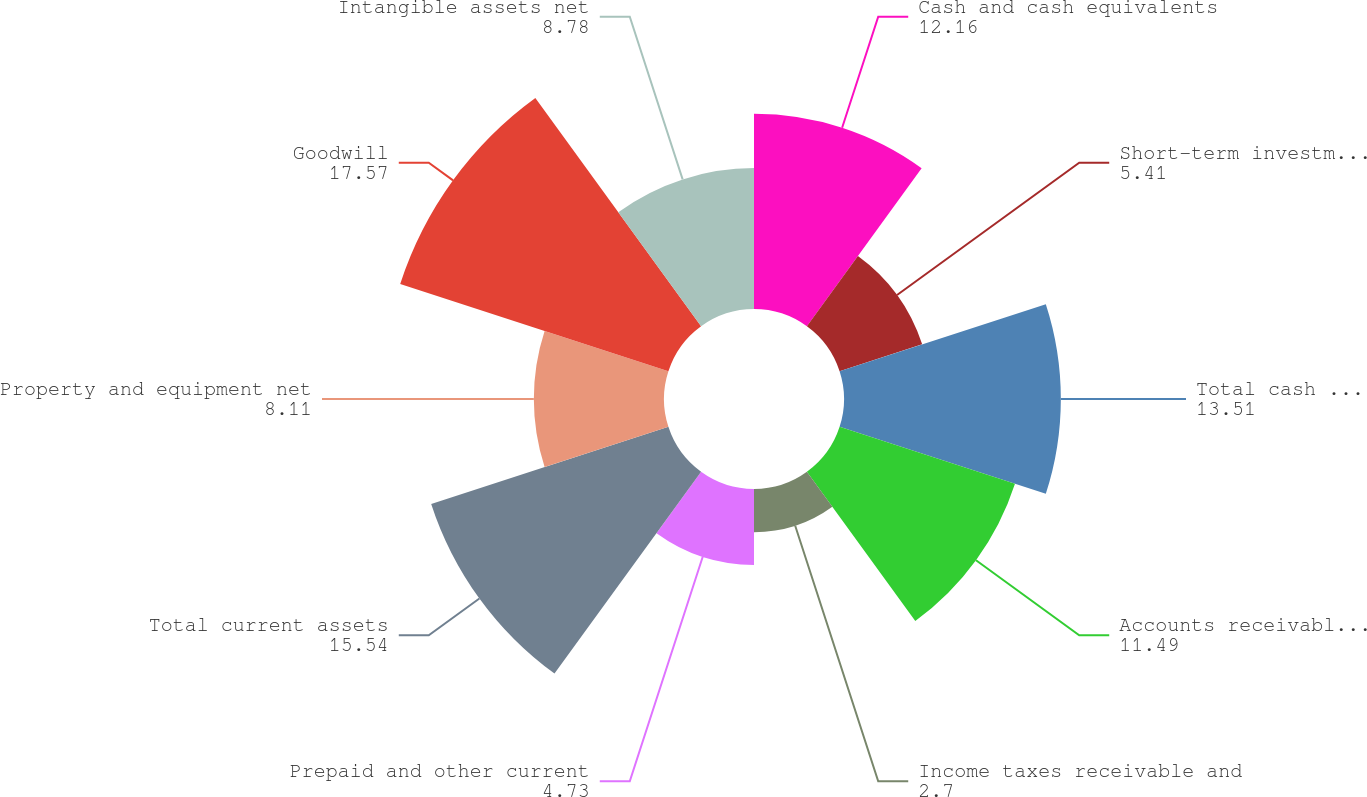Convert chart to OTSL. <chart><loc_0><loc_0><loc_500><loc_500><pie_chart><fcel>Cash and cash equivalents<fcel>Short-term investments<fcel>Total cash cash equivalents<fcel>Accounts receivable net of<fcel>Income taxes receivable and<fcel>Prepaid and other current<fcel>Total current assets<fcel>Property and equipment net<fcel>Goodwill<fcel>Intangible assets net<nl><fcel>12.16%<fcel>5.41%<fcel>13.51%<fcel>11.49%<fcel>2.7%<fcel>4.73%<fcel>15.54%<fcel>8.11%<fcel>17.57%<fcel>8.78%<nl></chart> 